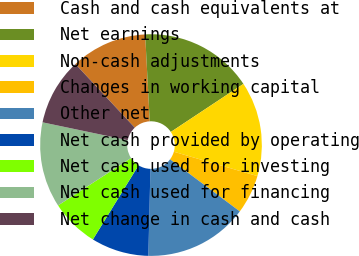Convert chart. <chart><loc_0><loc_0><loc_500><loc_500><pie_chart><fcel>Cash and cash equivalents at<fcel>Net earnings<fcel>Non-cash adjustments<fcel>Changes in working capital<fcel>Other net<fcel>Net cash provided by operating<fcel>Net cash used for investing<fcel>Net cash used for financing<fcel>Net change in cash and cash<nl><fcel>11.11%<fcel>16.53%<fcel>13.82%<fcel>5.7%<fcel>15.17%<fcel>8.4%<fcel>7.05%<fcel>12.46%<fcel>9.76%<nl></chart> 